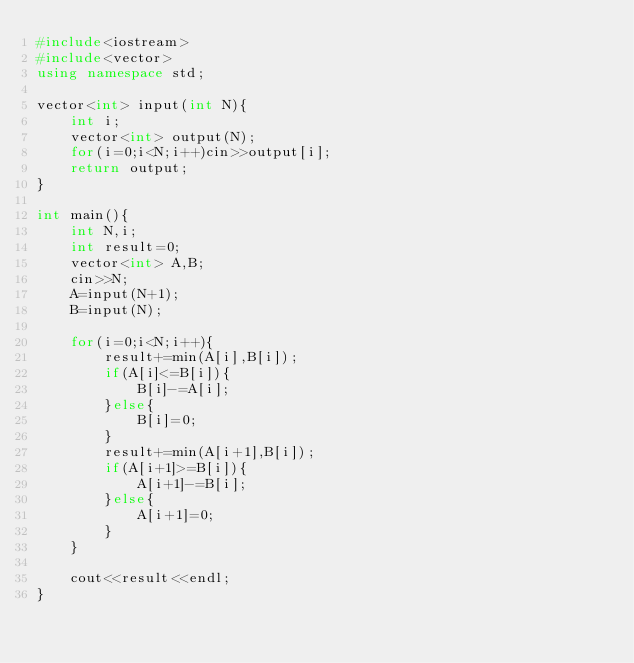<code> <loc_0><loc_0><loc_500><loc_500><_C++_>#include<iostream>
#include<vector>
using namespace std;

vector<int> input(int N){
    int i;
    vector<int> output(N);
    for(i=0;i<N;i++)cin>>output[i];
    return output;
}

int main(){
    int N,i;
    int result=0;
    vector<int> A,B;
    cin>>N;
    A=input(N+1);
    B=input(N);

    for(i=0;i<N;i++){
        result+=min(A[i],B[i]);
        if(A[i]<=B[i]){
            B[i]-=A[i];
        }else{
            B[i]=0;
        }
        result+=min(A[i+1],B[i]);
        if(A[i+1]>=B[i]){
            A[i+1]-=B[i];
        }else{
            A[i+1]=0;
        }
    }

    cout<<result<<endl;
}</code> 